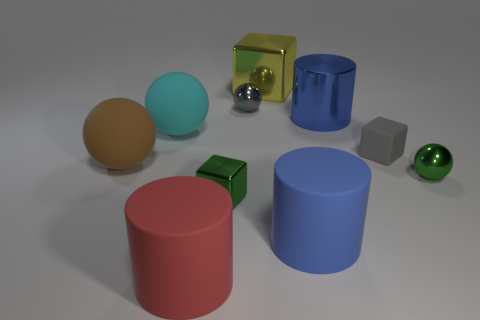There is a thing that is the same color as the large metallic cylinder; what size is it?
Your response must be concise. Large. There is a thing that is the same color as the metal cylinder; what is its shape?
Offer a terse response. Cylinder. There is a sphere on the right side of the large metallic cube that is to the right of the green cube; how big is it?
Offer a terse response. Small. Is there any other thing of the same color as the matte cube?
Your response must be concise. Yes. Are the small thing to the right of the small rubber object and the blue cylinder in front of the small gray matte cube made of the same material?
Your response must be concise. No. There is a small object that is both on the right side of the big block and behind the large brown matte ball; what material is it?
Provide a succinct answer. Rubber. There is a tiny matte thing; is its shape the same as the green metal thing on the right side of the big yellow metal object?
Make the answer very short. No. There is a tiny green object that is on the left side of the tiny green object that is to the right of the tiny gray metallic ball that is in front of the yellow object; what is its material?
Offer a very short reply. Metal. What number of other objects are there of the same size as the blue rubber cylinder?
Offer a very short reply. 5. Does the big block have the same color as the metallic cylinder?
Give a very brief answer. No. 